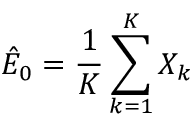Convert formula to latex. <formula><loc_0><loc_0><loc_500><loc_500>\hat { E } _ { 0 } = \frac { 1 } { K } \sum _ { k = 1 } ^ { K } X _ { k }</formula> 